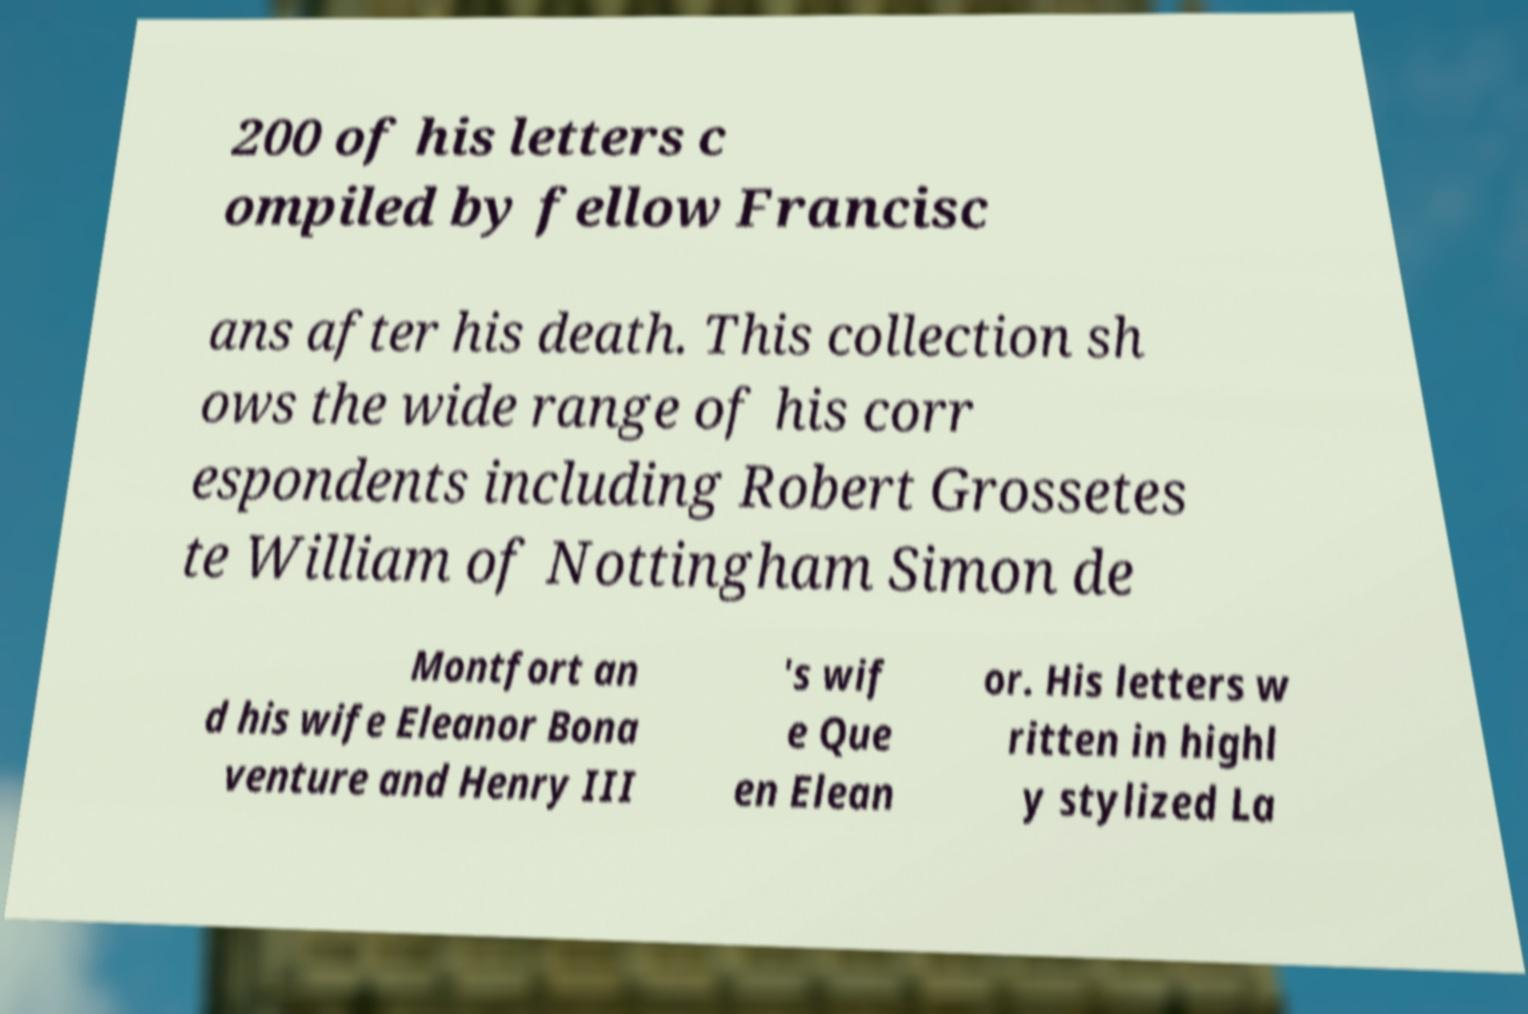Please identify and transcribe the text found in this image. 200 of his letters c ompiled by fellow Francisc ans after his death. This collection sh ows the wide range of his corr espondents including Robert Grossetes te William of Nottingham Simon de Montfort an d his wife Eleanor Bona venture and Henry III 's wif e Que en Elean or. His letters w ritten in highl y stylized La 